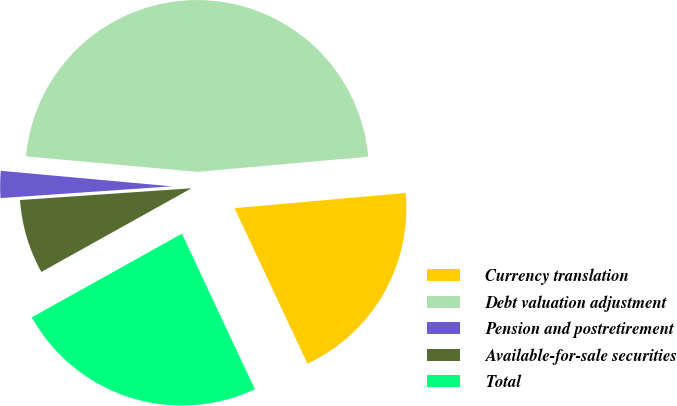Convert chart to OTSL. <chart><loc_0><loc_0><loc_500><loc_500><pie_chart><fcel>Currency translation<fcel>Debt valuation adjustment<fcel>Pension and postretirement<fcel>Available-for-sale securities<fcel>Total<nl><fcel>19.43%<fcel>47.15%<fcel>2.53%<fcel>7.0%<fcel>23.89%<nl></chart> 